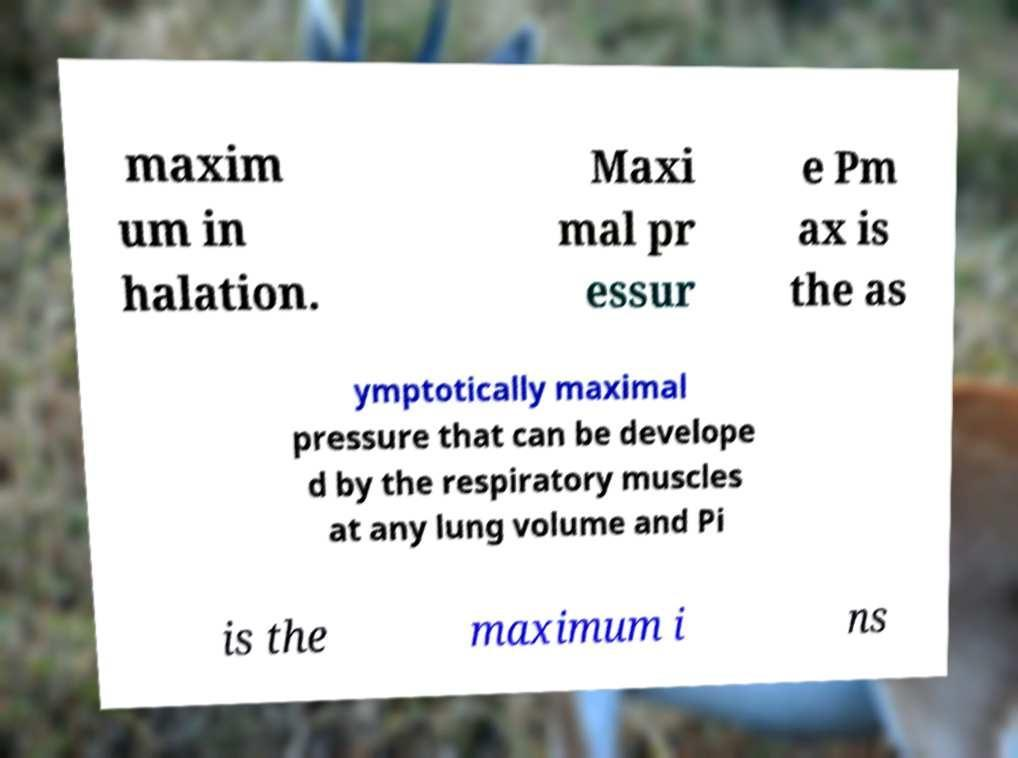Could you extract and type out the text from this image? maxim um in halation. Maxi mal pr essur e Pm ax is the as ymptotically maximal pressure that can be develope d by the respiratory muscles at any lung volume and Pi is the maximum i ns 